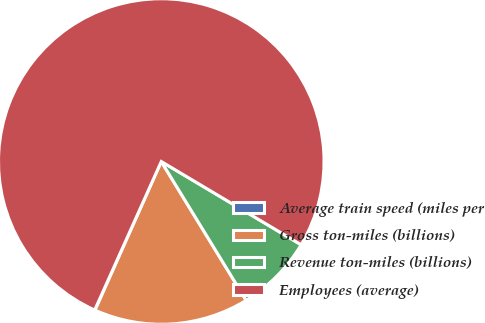<chart> <loc_0><loc_0><loc_500><loc_500><pie_chart><fcel>Average train speed (miles per<fcel>Gross ton-miles (billions)<fcel>Revenue ton-miles (billions)<fcel>Employees (average)<nl><fcel>0.04%<fcel>15.4%<fcel>7.72%<fcel>76.83%<nl></chart> 